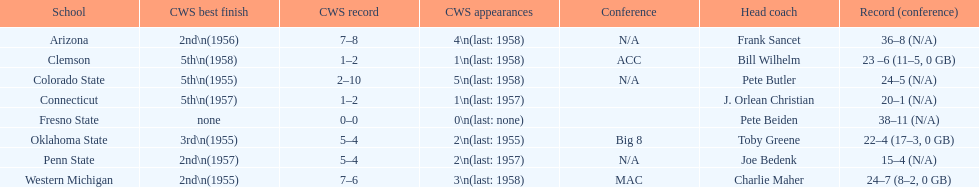What is the only team that achieved less than 20 wins? Penn State. 